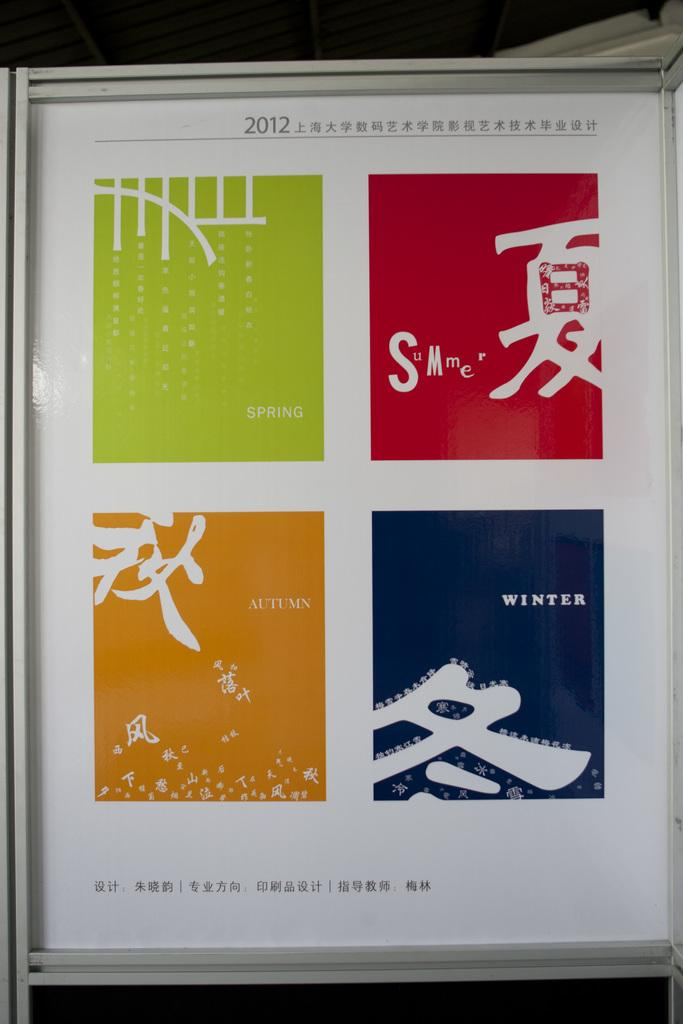<image>
Offer a succinct explanation of the picture presented. All four seasons are portrayed with different colors in at 2012 poster. 